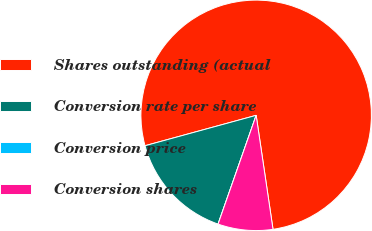<chart> <loc_0><loc_0><loc_500><loc_500><pie_chart><fcel>Shares outstanding (actual<fcel>Conversion rate per share<fcel>Conversion price<fcel>Conversion shares<nl><fcel>76.91%<fcel>15.39%<fcel>0.0%<fcel>7.7%<nl></chart> 